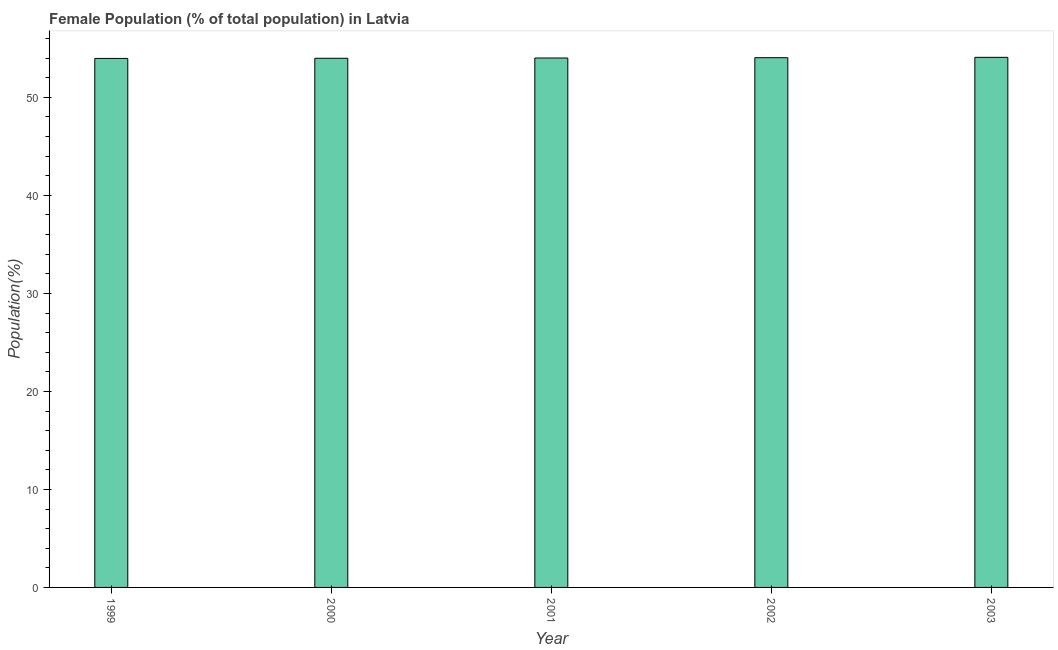Does the graph contain any zero values?
Your answer should be compact. No. What is the title of the graph?
Provide a short and direct response. Female Population (% of total population) in Latvia. What is the label or title of the X-axis?
Ensure brevity in your answer.  Year. What is the label or title of the Y-axis?
Offer a very short reply. Population(%). What is the female population in 2003?
Give a very brief answer. 54.09. Across all years, what is the maximum female population?
Your answer should be very brief. 54.09. Across all years, what is the minimum female population?
Make the answer very short. 53.98. In which year was the female population maximum?
Your response must be concise. 2003. What is the sum of the female population?
Provide a short and direct response. 270.12. What is the difference between the female population in 2001 and 2002?
Ensure brevity in your answer.  -0.03. What is the average female population per year?
Provide a short and direct response. 54.02. What is the median female population?
Keep it short and to the point. 54.02. In how many years, is the female population greater than 54 %?
Provide a short and direct response. 3. What is the ratio of the female population in 2002 to that in 2003?
Your answer should be very brief. 1. Is the female population in 2000 less than that in 2001?
Offer a terse response. Yes. What is the difference between the highest and the second highest female population?
Give a very brief answer. 0.04. What is the difference between the highest and the lowest female population?
Provide a short and direct response. 0.11. How many years are there in the graph?
Keep it short and to the point. 5. What is the Population(%) of 1999?
Offer a very short reply. 53.98. What is the Population(%) of 2000?
Your answer should be compact. 53.99. What is the Population(%) in 2001?
Your answer should be compact. 54.02. What is the Population(%) of 2002?
Your response must be concise. 54.05. What is the Population(%) of 2003?
Offer a terse response. 54.09. What is the difference between the Population(%) in 1999 and 2000?
Give a very brief answer. -0.02. What is the difference between the Population(%) in 1999 and 2001?
Give a very brief answer. -0.04. What is the difference between the Population(%) in 1999 and 2002?
Offer a very short reply. -0.07. What is the difference between the Population(%) in 1999 and 2003?
Offer a terse response. -0.11. What is the difference between the Population(%) in 2000 and 2001?
Ensure brevity in your answer.  -0.03. What is the difference between the Population(%) in 2000 and 2002?
Offer a very short reply. -0.06. What is the difference between the Population(%) in 2000 and 2003?
Your answer should be very brief. -0.1. What is the difference between the Population(%) in 2001 and 2002?
Your answer should be compact. -0.03. What is the difference between the Population(%) in 2001 and 2003?
Offer a terse response. -0.07. What is the difference between the Population(%) in 2002 and 2003?
Keep it short and to the point. -0.04. What is the ratio of the Population(%) in 1999 to that in 2000?
Your answer should be very brief. 1. What is the ratio of the Population(%) in 1999 to that in 2001?
Your answer should be compact. 1. What is the ratio of the Population(%) in 1999 to that in 2002?
Make the answer very short. 1. What is the ratio of the Population(%) in 2000 to that in 2001?
Offer a very short reply. 1. What is the ratio of the Population(%) in 2000 to that in 2002?
Make the answer very short. 1. What is the ratio of the Population(%) in 2000 to that in 2003?
Offer a very short reply. 1. What is the ratio of the Population(%) in 2001 to that in 2002?
Provide a short and direct response. 1. What is the ratio of the Population(%) in 2001 to that in 2003?
Your answer should be very brief. 1. 